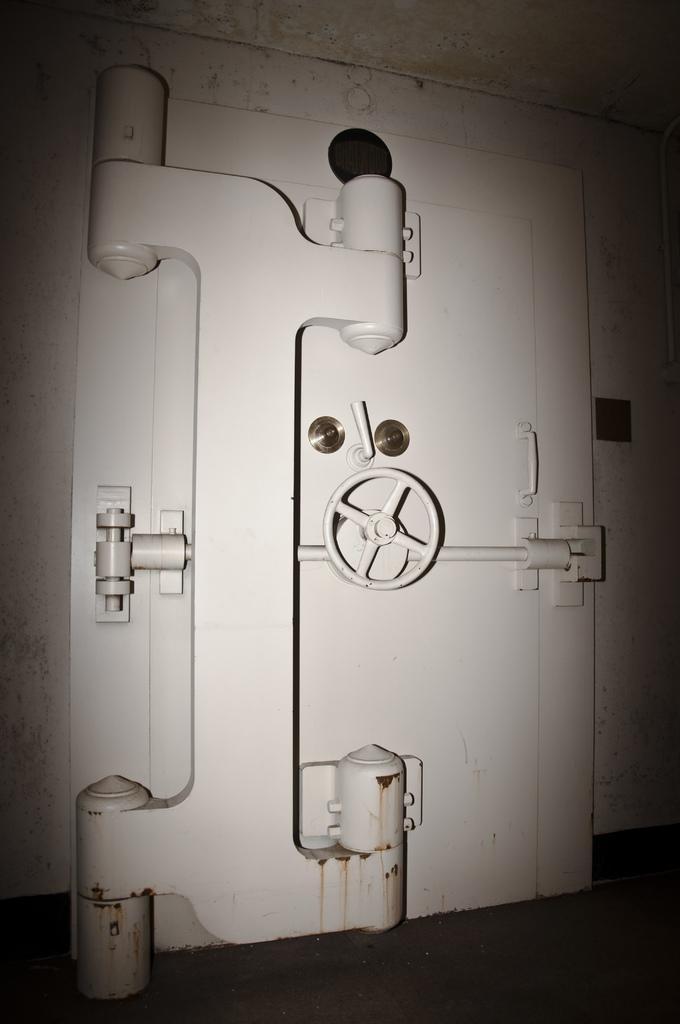How would you summarize this image in a sentence or two? In this picture we can see iron locker door, wall, handle and floor. 